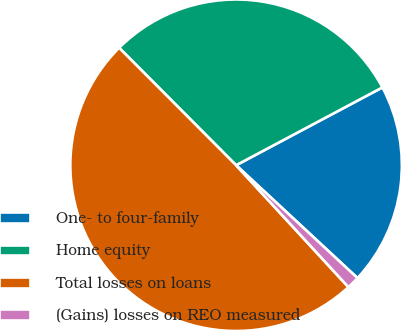Convert chart to OTSL. <chart><loc_0><loc_0><loc_500><loc_500><pie_chart><fcel>One- to four-family<fcel>Home equity<fcel>Total losses on loans<fcel>(Gains) losses on REO measured<nl><fcel>19.7%<fcel>29.69%<fcel>49.39%<fcel>1.23%<nl></chart> 